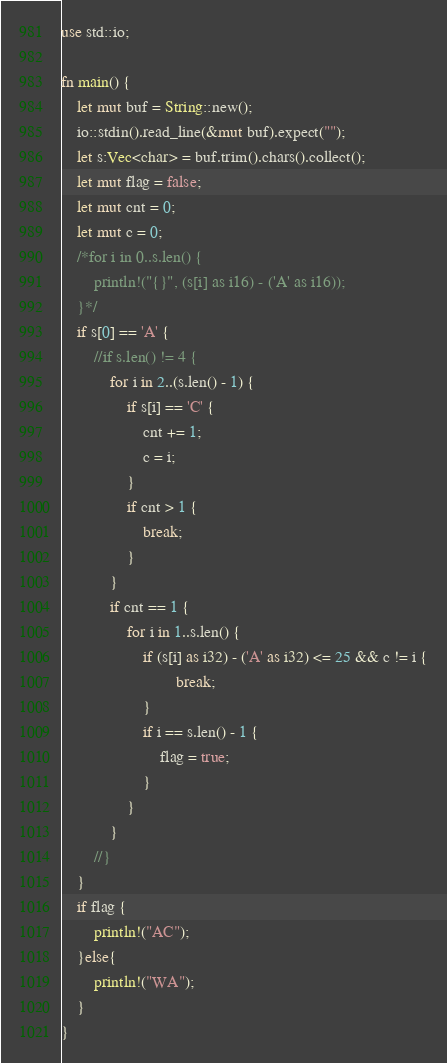<code> <loc_0><loc_0><loc_500><loc_500><_Rust_>use std::io;

fn main() {
	let mut buf = String::new();
	io::stdin().read_line(&mut buf).expect("");
	let s:Vec<char> = buf.trim().chars().collect();
	let mut flag = false;
	let mut cnt = 0;
	let mut c = 0;
	/*for i in 0..s.len() {
		println!("{}", (s[i] as i16) - ('A' as i16));
	}*/
	if s[0] == 'A' {
		//if s.len() != 4 {
			for i in 2..(s.len() - 1) {
				if s[i] == 'C' {
					cnt += 1;
					c = i;
				}
				if cnt > 1 {
					break;
				}
			}
			if cnt == 1 {
				for i in 1..s.len() {
					if (s[i] as i32) - ('A' as i32) <= 25 && c != i {
							break;
					}
					if i == s.len() - 1 {
						flag = true;
					}
				}
			}
		//}
	}
	if flag {
		println!("AC");
	}else{
		println!("WA");
	}
}</code> 